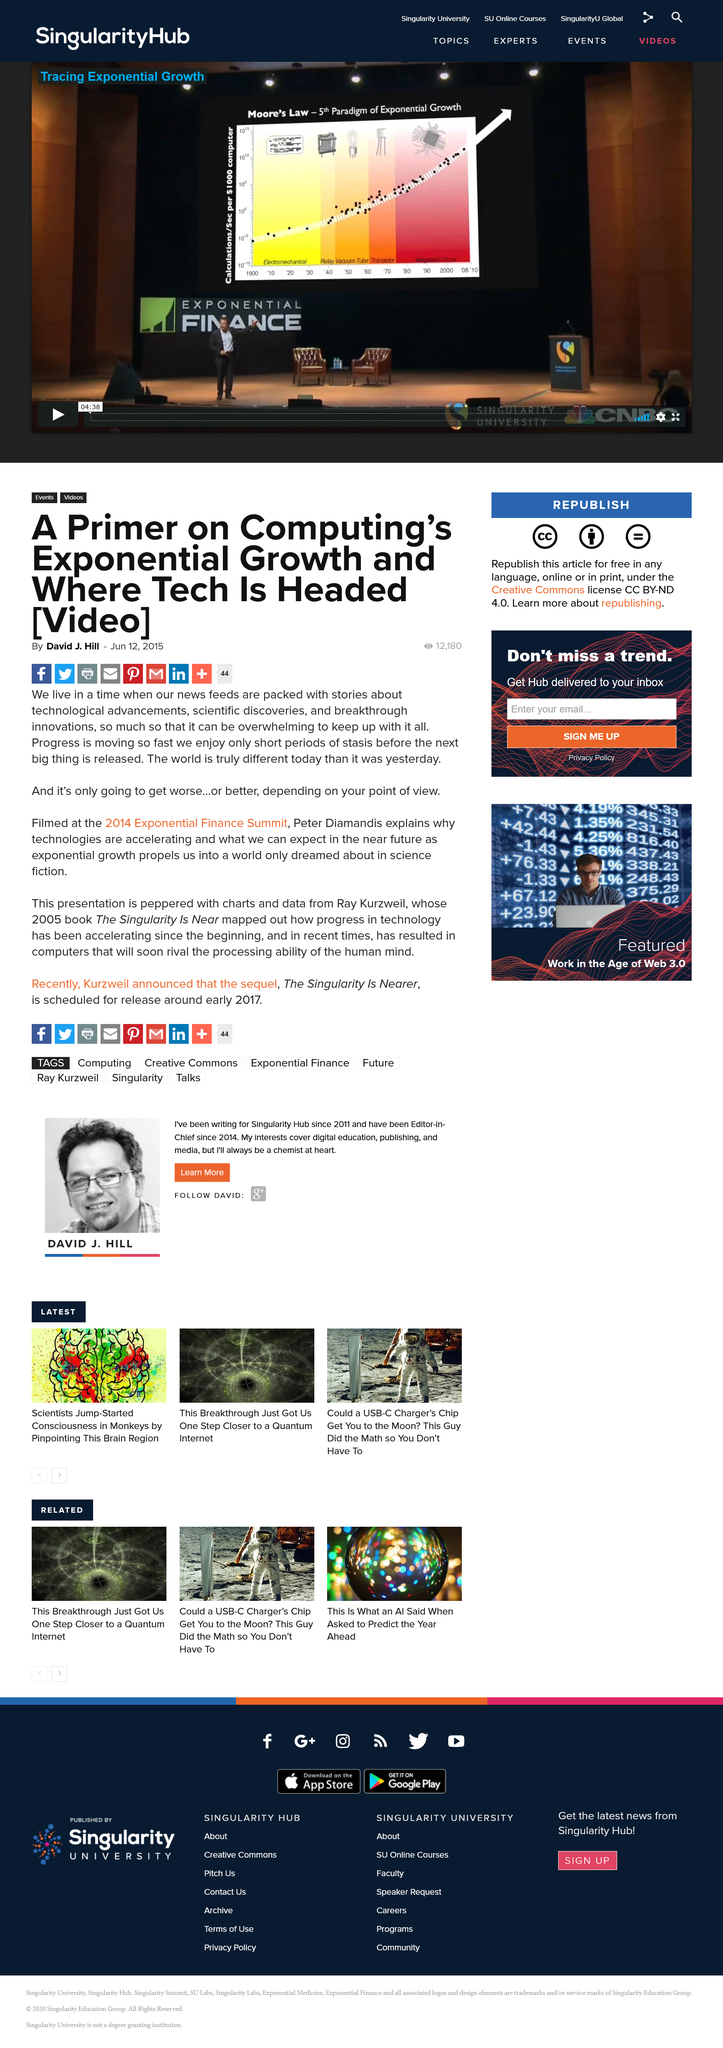Indicate a few pertinent items in this graphic. On June 12th, 2015, the article was published. The article refers to the Exponential Finance Summit that took place in 2014. In 2005, Ray Kurzweil published his book. 